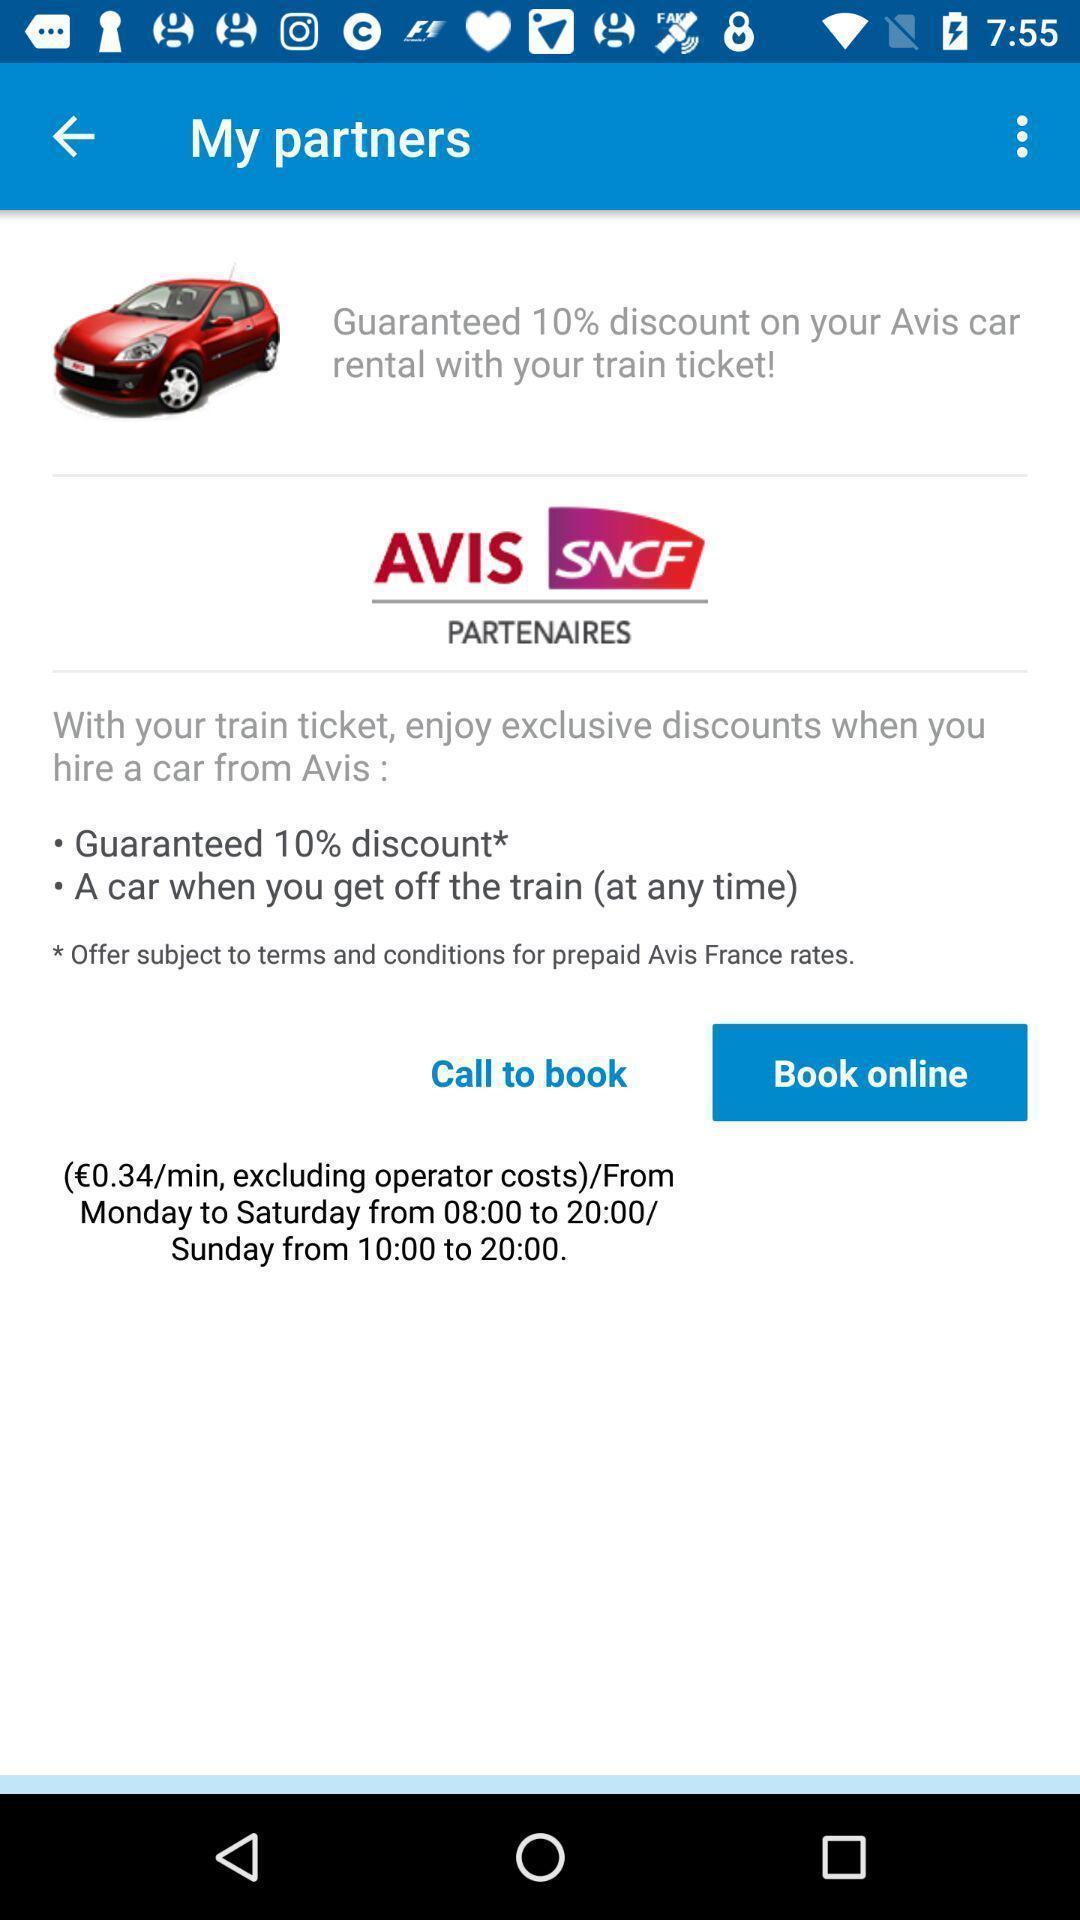Tell me what you see in this picture. Screen displaying vehicle information and multiple booking options. 